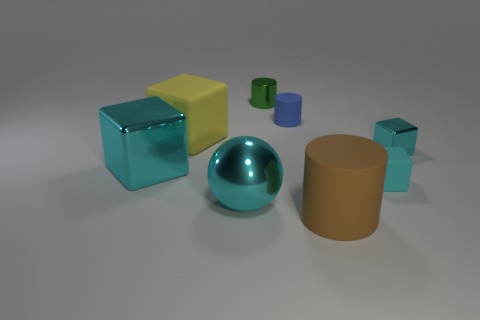Is there a cyan metallic block that is in front of the metallic object on the right side of the brown cylinder?
Offer a terse response. Yes. Are there more cyan objects in front of the yellow object than tiny matte cylinders to the right of the tiny cyan rubber block?
Offer a terse response. Yes. There is a large ball that is the same color as the large metallic cube; what is its material?
Ensure brevity in your answer.  Metal. How many metallic cylinders are the same color as the tiny rubber cylinder?
Your answer should be very brief. 0. There is a tiny object in front of the big cyan metal block; is its color the same as the big cube that is in front of the yellow matte cube?
Make the answer very short. Yes. There is a green thing; are there any big matte things in front of it?
Provide a succinct answer. Yes. What material is the brown object?
Keep it short and to the point. Rubber. What is the shape of the metal object on the right side of the green cylinder?
Offer a terse response. Cube. What is the size of the sphere that is the same color as the large metal block?
Ensure brevity in your answer.  Large. Is there a blue matte cylinder of the same size as the metal ball?
Offer a terse response. No. 